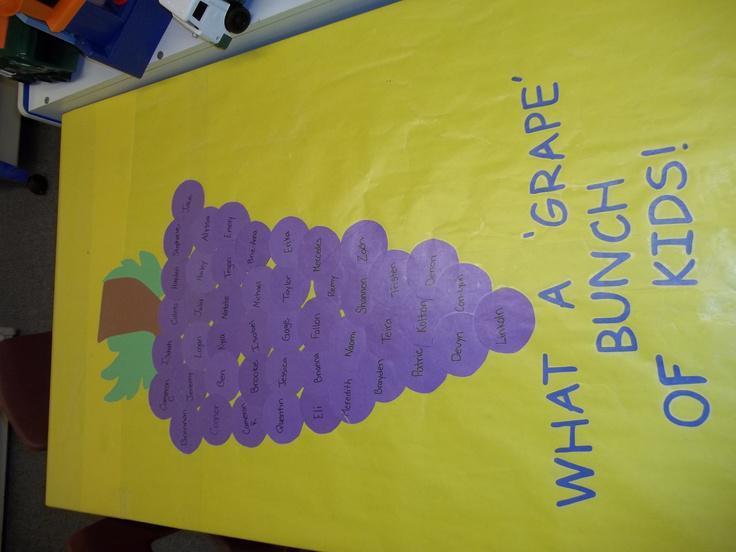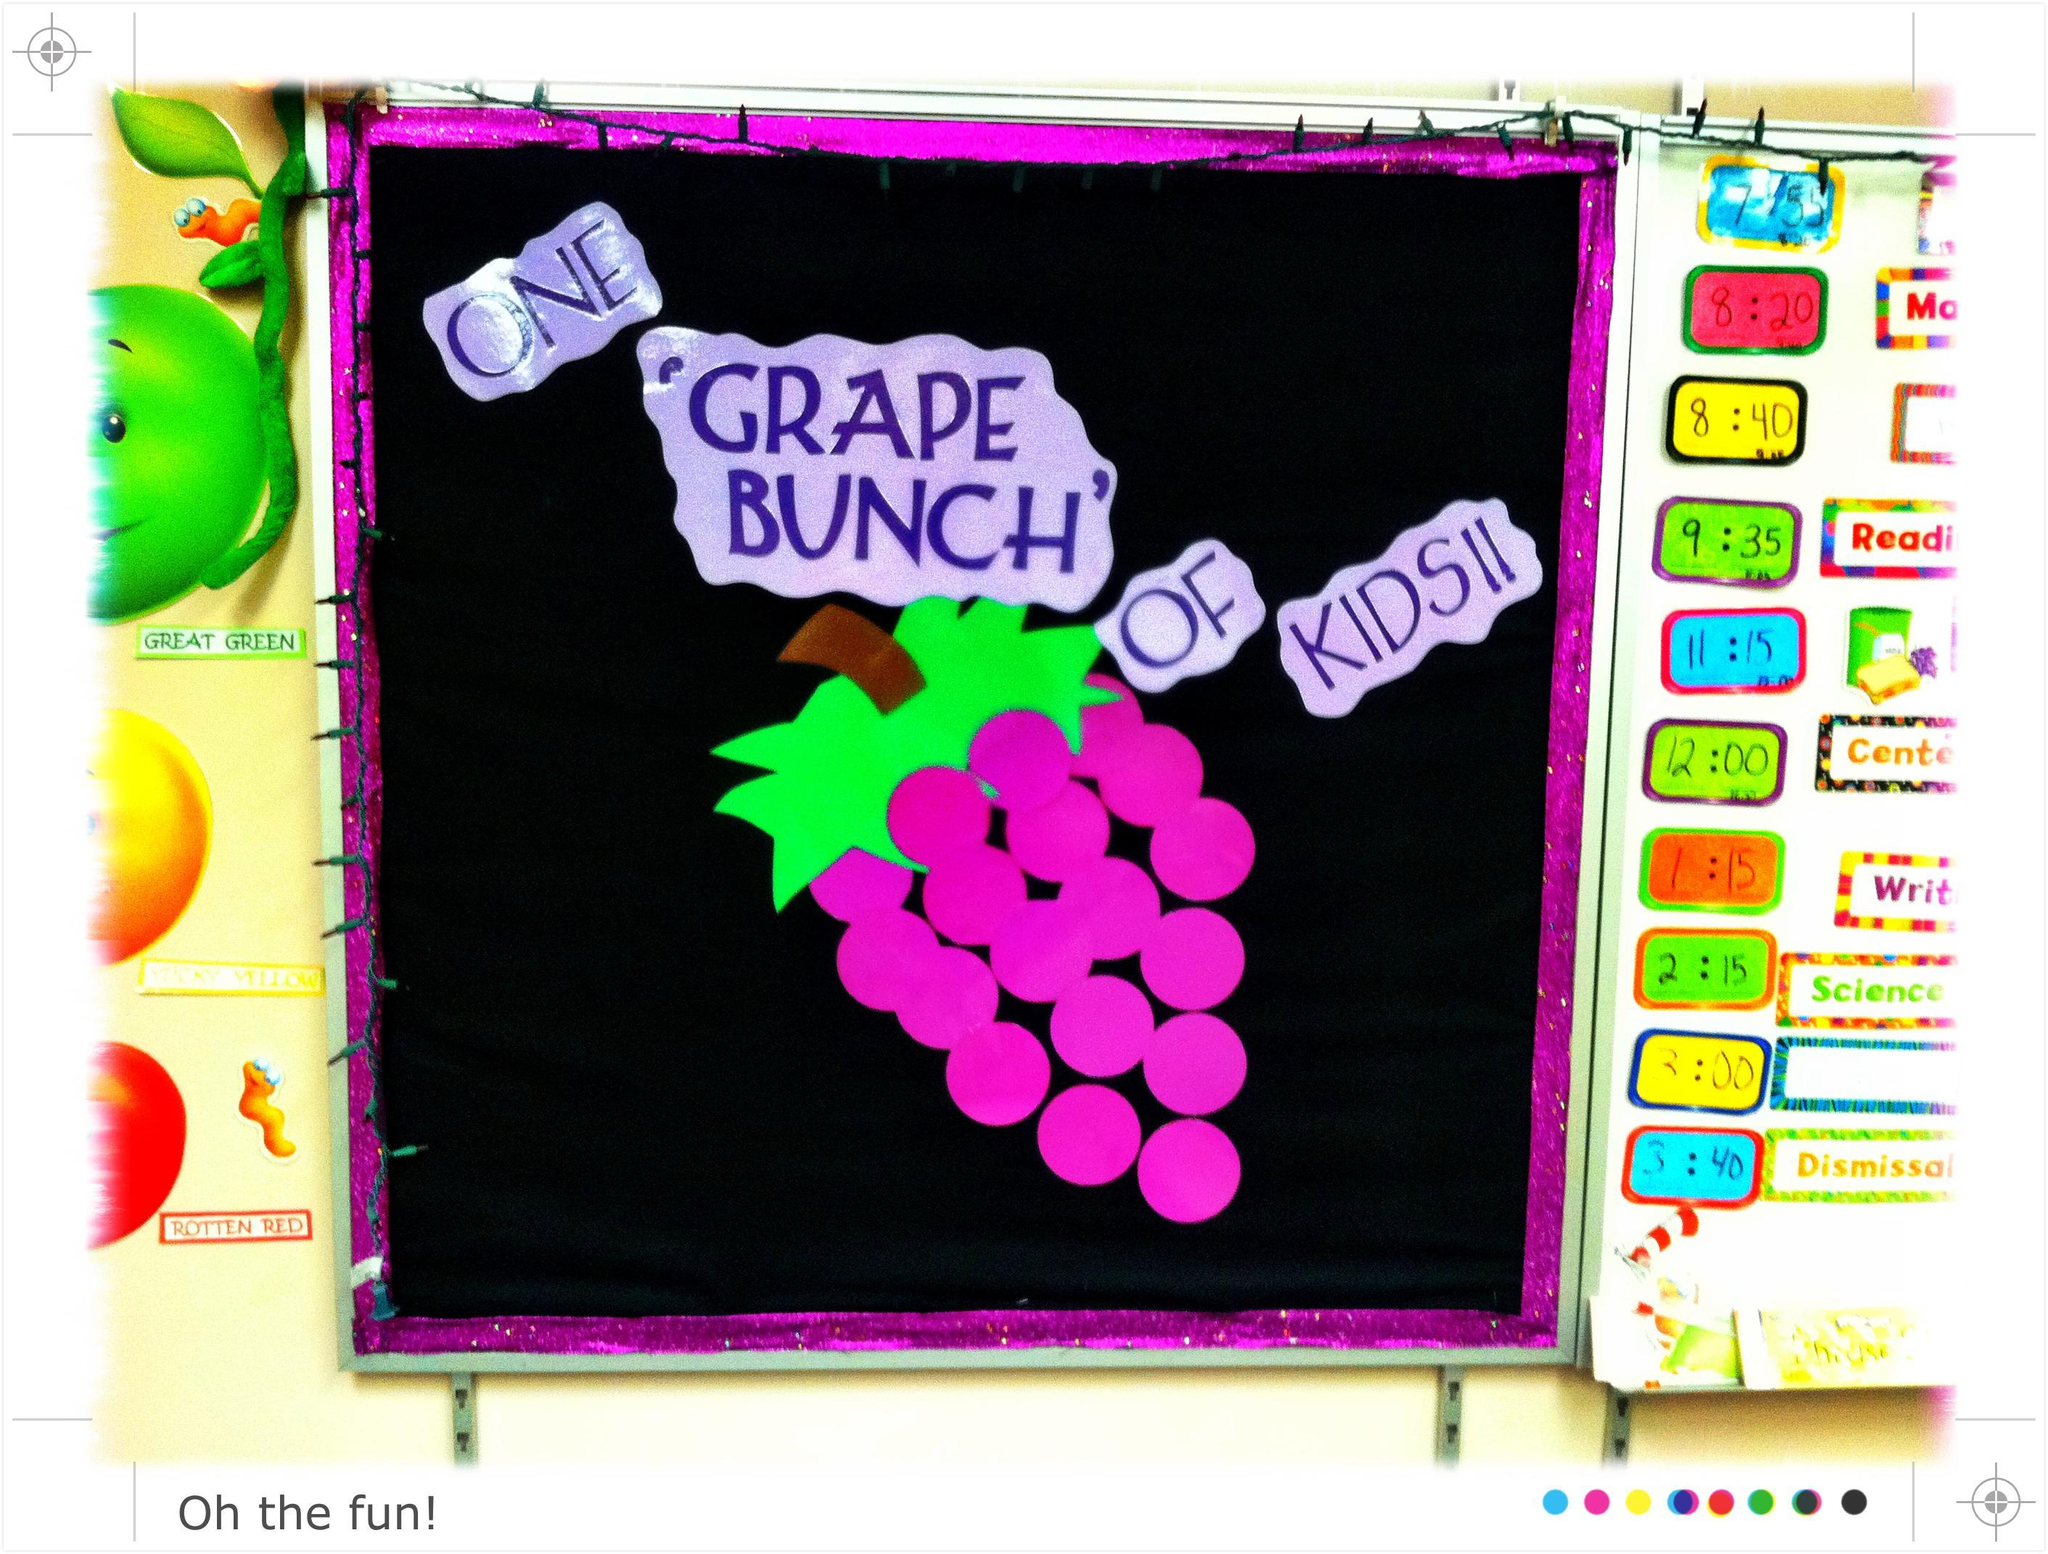The first image is the image on the left, the second image is the image on the right. Assess this claim about the two images: "Balloons hang from a poster in the image on the right.". Correct or not? Answer yes or no. No. The first image is the image on the left, the second image is the image on the right. Considering the images on both sides, is "The right image shows purple balloons used to represent grapes in a cluster, and the left image shows childrens' faces in the center of purple circles." valid? Answer yes or no. No. 